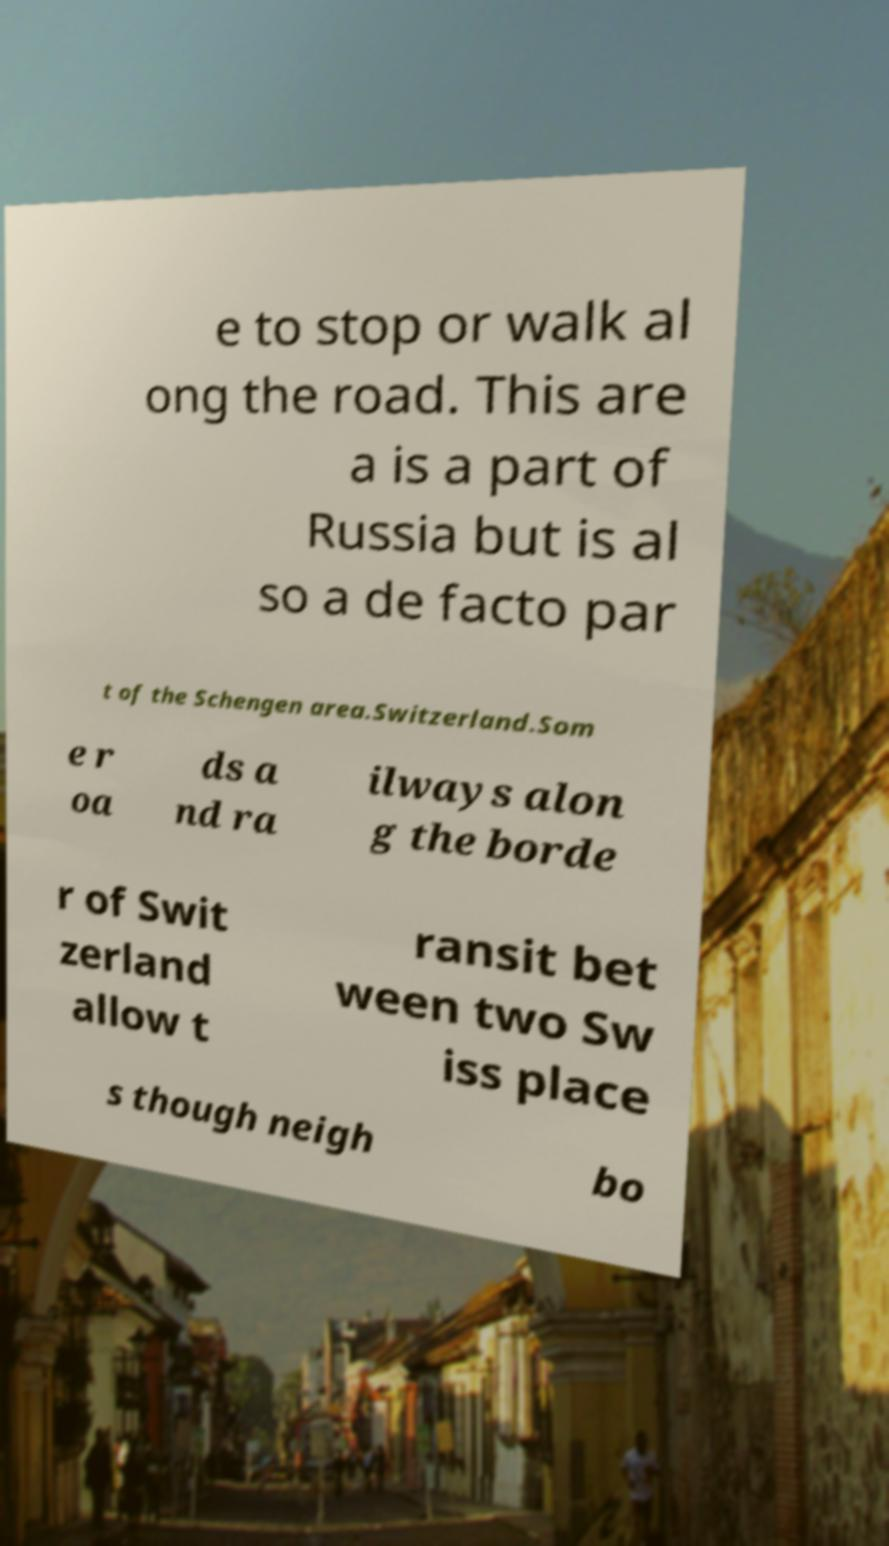Please read and relay the text visible in this image. What does it say? e to stop or walk al ong the road. This are a is a part of Russia but is al so a de facto par t of the Schengen area.Switzerland.Som e r oa ds a nd ra ilways alon g the borde r of Swit zerland allow t ransit bet ween two Sw iss place s though neigh bo 